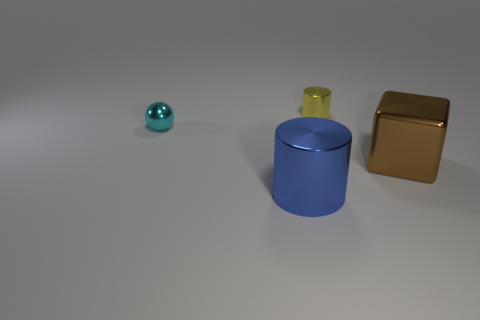What number of shiny things are both behind the blue metallic cylinder and on the right side of the small ball?
Your response must be concise. 2. What size is the blue object that is the same material as the large brown block?
Your answer should be very brief. Large. What number of small yellow shiny things are the same shape as the blue shiny thing?
Make the answer very short. 1. Is the number of tiny metallic things that are left of the large blue metallic thing greater than the number of large rubber balls?
Give a very brief answer. Yes. The shiny thing that is both on the left side of the tiny shiny cylinder and behind the big metallic cylinder has what shape?
Make the answer very short. Sphere. Is the brown metal object the same size as the yellow metallic cylinder?
Make the answer very short. No. There is a brown metal cube; what number of tiny yellow cylinders are on the right side of it?
Your response must be concise. 0. Is the number of big brown metal objects behind the brown object the same as the number of yellow cylinders behind the yellow cylinder?
Your answer should be very brief. Yes. Is the shape of the metallic object behind the tiny shiny sphere the same as  the large blue metallic thing?
Your answer should be compact. Yes. Is the size of the brown shiny cube the same as the metallic cylinder that is in front of the small yellow shiny object?
Your answer should be very brief. Yes. 